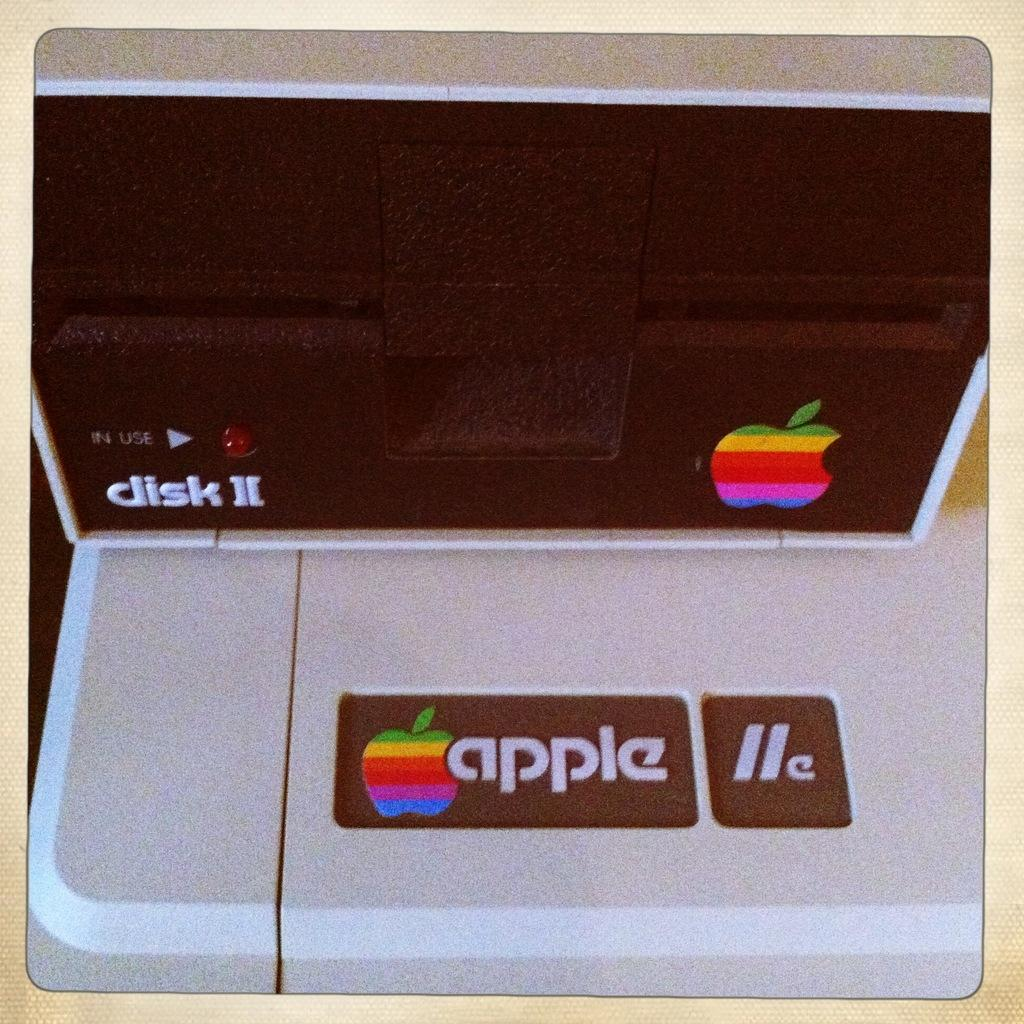<image>
Create a compact narrative representing the image presented. An old Apple computer has a light an arrow next to an In Use indicator. 